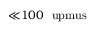Convert formula to latex. <formula><loc_0><loc_0><loc_500><loc_500>{ \ll } 1 0 0 \ u p m u s</formula> 